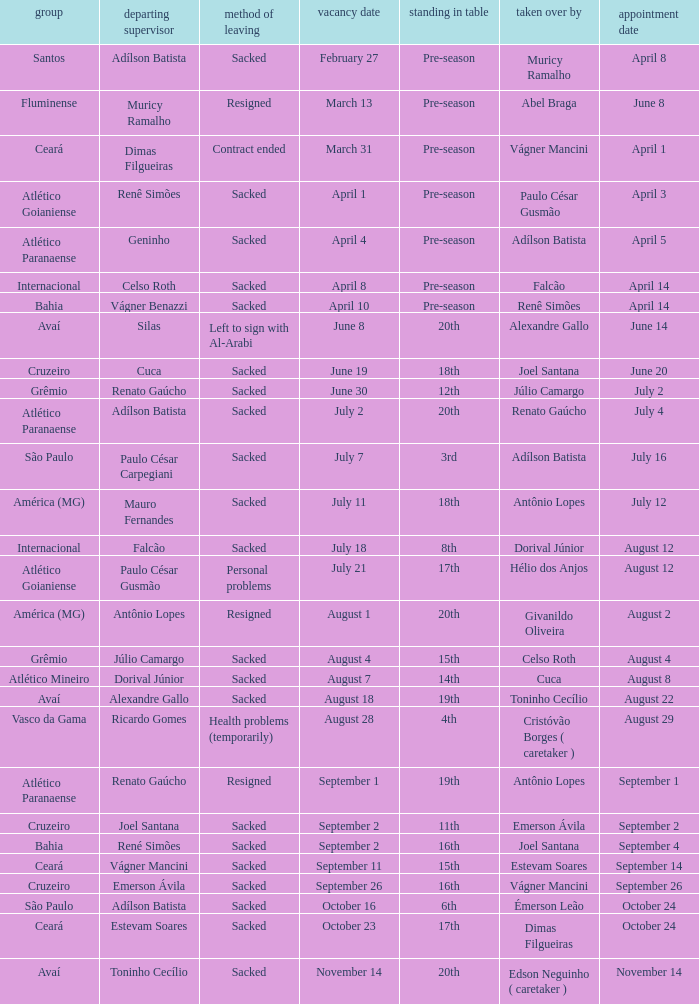Who was replaced as manager on June 20? Cuca. 